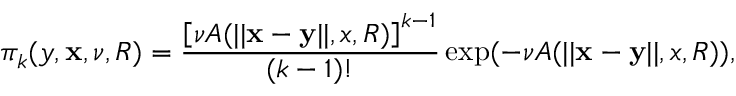<formula> <loc_0><loc_0><loc_500><loc_500>\pi _ { k } ( y , \mathbf x , \nu , R ) = \frac { \left [ \nu A ( | | \mathbf x - \mathbf y | | , x , R ) \right ] ^ { k - 1 } } { ( k - 1 ) ! } \exp ( - \nu A ( | | \mathbf x - \mathbf y | | , x , R ) ) ,</formula> 